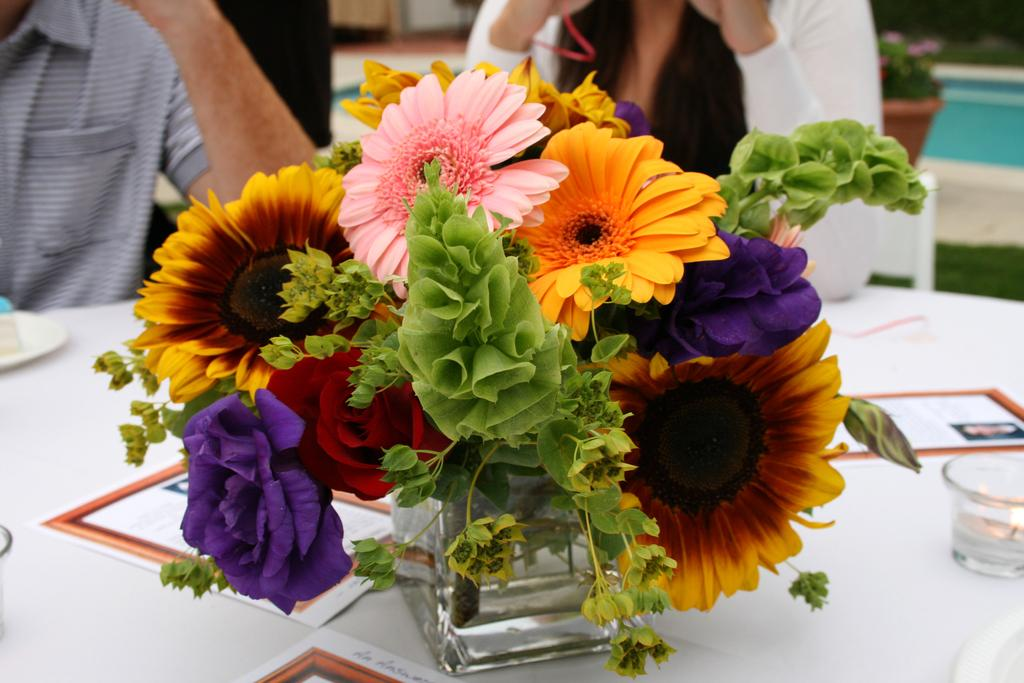What object is present on the table in the image? There is a flower pot on the white table in the image. What is the color of the table? The table is white. What is the girl in the image wearing? The girl is wearing a white t-shirt. What is the girl's position in the image? The girl is sitting on a chair. What type of brass instrument is the girl playing in the image? There is no brass instrument present in the image; the girl is sitting on a chair and wearing a white t-shirt. 